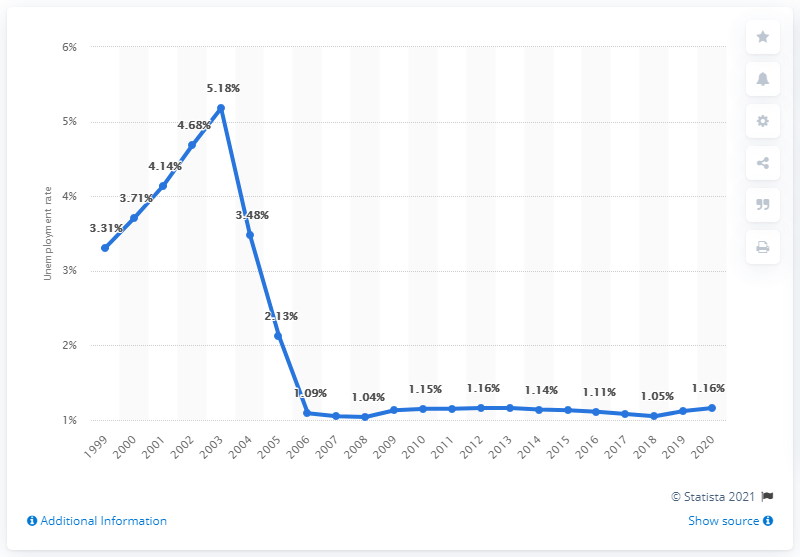Mention a couple of crucial points in this snapshot. In 2020, the unemployment rate in Tonga was 1.16%. 